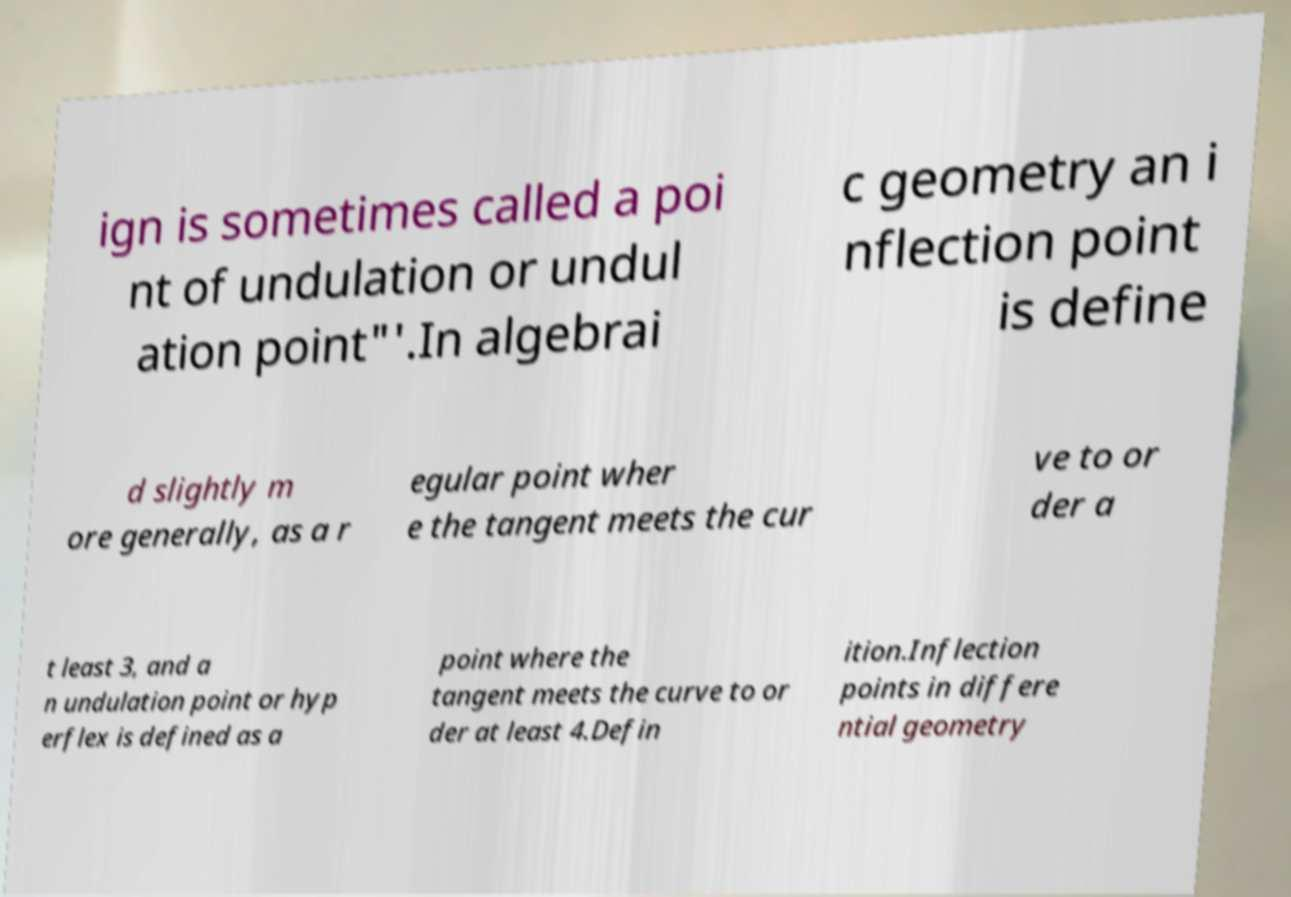There's text embedded in this image that I need extracted. Can you transcribe it verbatim? ign is sometimes called a poi nt of undulation or undul ation point"'.In algebrai c geometry an i nflection point is define d slightly m ore generally, as a r egular point wher e the tangent meets the cur ve to or der a t least 3, and a n undulation point or hyp erflex is defined as a point where the tangent meets the curve to or der at least 4.Defin ition.Inflection points in differe ntial geometry 